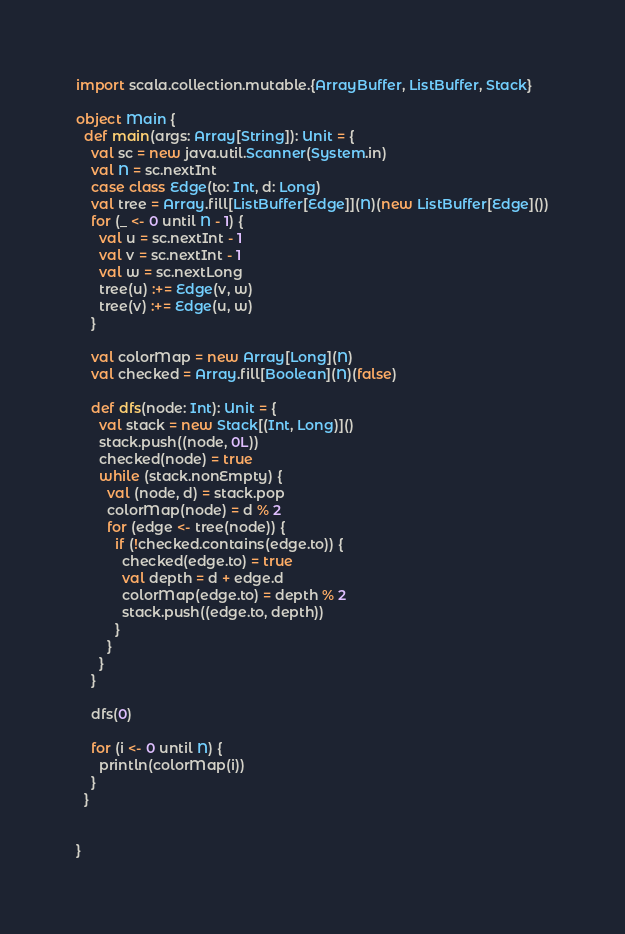<code> <loc_0><loc_0><loc_500><loc_500><_Scala_>import scala.collection.mutable.{ArrayBuffer, ListBuffer, Stack}

object Main {
  def main(args: Array[String]): Unit = {
    val sc = new java.util.Scanner(System.in)
    val N = sc.nextInt
    case class Edge(to: Int, d: Long)
    val tree = Array.fill[ListBuffer[Edge]](N)(new ListBuffer[Edge]())
    for (_ <- 0 until N - 1) {
      val u = sc.nextInt - 1
      val v = sc.nextInt - 1
      val w = sc.nextLong
      tree(u) :+= Edge(v, w)
      tree(v) :+= Edge(u, w)
    }

    val colorMap = new Array[Long](N)
    val checked = Array.fill[Boolean](N)(false)

    def dfs(node: Int): Unit = {
      val stack = new Stack[(Int, Long)]()
      stack.push((node, 0L))
      checked(node) = true
      while (stack.nonEmpty) {
        val (node, d) = stack.pop
        colorMap(node) = d % 2
        for (edge <- tree(node)) {
          if (!checked.contains(edge.to)) {
            checked(edge.to) = true
            val depth = d + edge.d
            colorMap(edge.to) = depth % 2
            stack.push((edge.to, depth))
          }
        }
      }
    }

    dfs(0)

    for (i <- 0 until N) {
      println(colorMap(i))
    }
  }


}</code> 